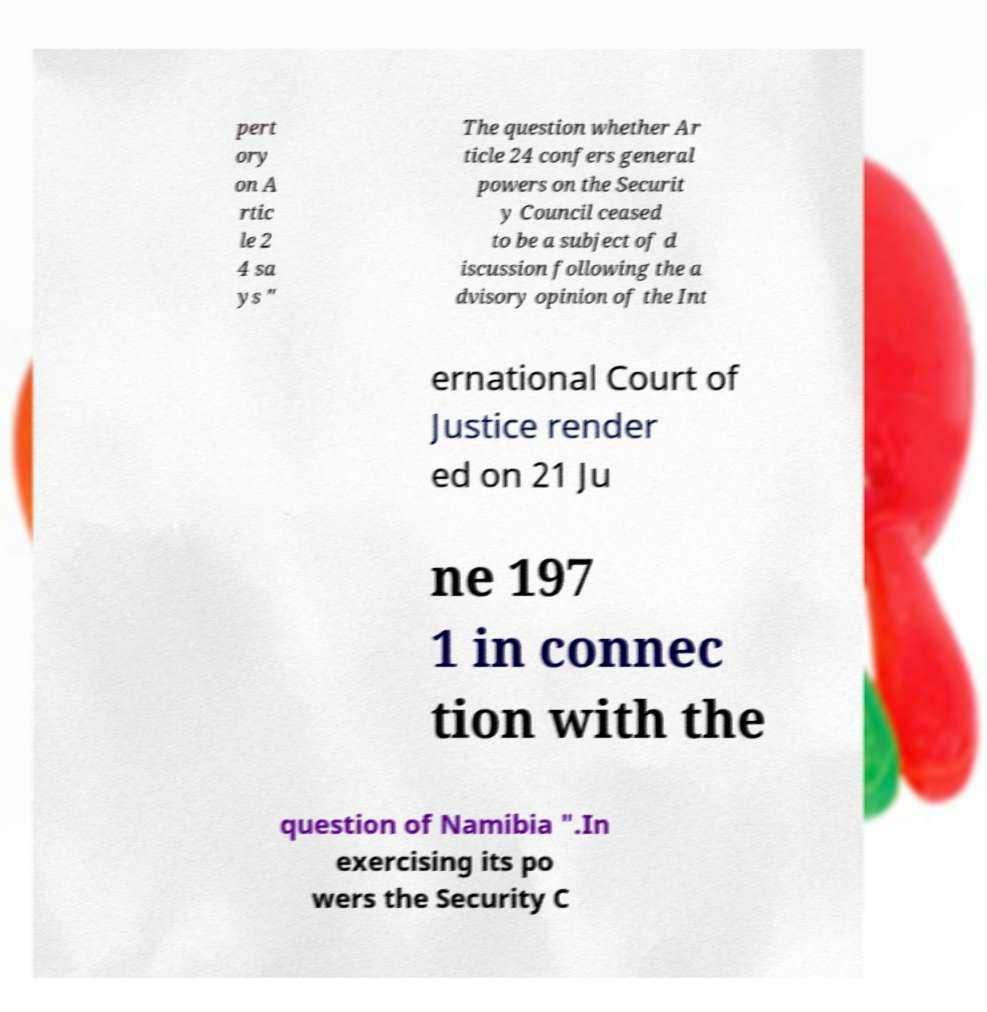Please read and relay the text visible in this image. What does it say? pert ory on A rtic le 2 4 sa ys " The question whether Ar ticle 24 confers general powers on the Securit y Council ceased to be a subject of d iscussion following the a dvisory opinion of the Int ernational Court of Justice render ed on 21 Ju ne 197 1 in connec tion with the question of Namibia ".In exercising its po wers the Security C 